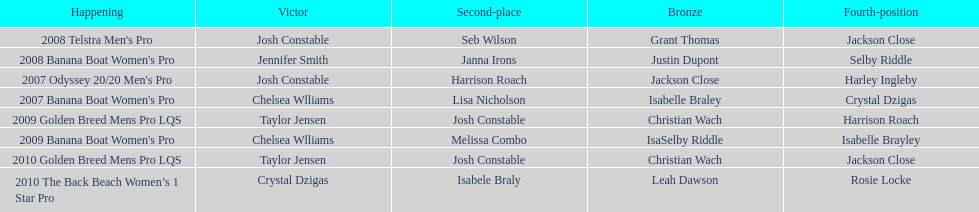Who completed the 2008 telstra men's pro following josh constable? Seb Wilson. 